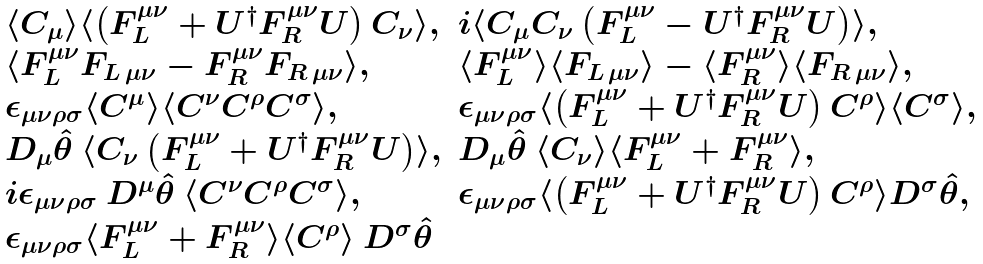<formula> <loc_0><loc_0><loc_500><loc_500>\begin{array} { l l } \langle C _ { \mu } \rangle \langle \left ( F _ { L } ^ { \mu \nu } + U ^ { \dagger } F _ { R } ^ { \mu \nu } U \right ) C _ { \nu } \rangle , & i \langle C _ { \mu } C _ { \nu } \left ( F _ { L } ^ { \mu \nu } - U ^ { \dagger } F _ { R } ^ { \mu \nu } U \right ) \rangle , \\ \langle F _ { L } ^ { \mu \nu } F _ { L \, \mu \nu } - F _ { R } ^ { \mu \nu } F _ { R \, \mu \nu } \rangle , & \langle F _ { L } ^ { \mu \nu } \rangle \langle F _ { L \, \mu \nu } \rangle - \langle F _ { R } ^ { \mu \nu } \rangle \langle F _ { R \, \mu \nu } \rangle , \\ \epsilon _ { \mu \nu \rho \sigma } \langle C ^ { \mu } \rangle \langle C ^ { \nu } C ^ { \rho } C ^ { \sigma } \rangle , & \epsilon _ { \mu \nu \rho \sigma } \langle \left ( F _ { L } ^ { \mu \nu } + U ^ { \dagger } F _ { R } ^ { \mu \nu } U \right ) C ^ { \rho } \rangle \langle C ^ { \sigma } \rangle , \\ D _ { \mu } \hat { \theta } \ \langle C _ { \nu } \left ( F _ { L } ^ { \mu \nu } + U ^ { \dagger } F _ { R } ^ { \mu \nu } U \right ) \rangle , & D _ { \mu } \hat { \theta } \ \langle C _ { \nu } \rangle \langle F _ { L } ^ { \mu \nu } + F _ { R } ^ { \mu \nu } \rangle , \\ i \epsilon _ { \mu \nu \rho \sigma } \ D ^ { \mu } \hat { \theta } \ \langle C ^ { \nu } C ^ { \rho } C ^ { \sigma } \rangle , & \epsilon _ { \mu \nu \rho \sigma } \langle \left ( F _ { L } ^ { \mu \nu } + U ^ { \dagger } F _ { R } ^ { \mu \nu } U \right ) C ^ { \rho } \rangle D ^ { \sigma } \hat { \theta } , \\ \epsilon _ { \mu \nu \rho \sigma } \langle F _ { L } ^ { \mu \nu } + F _ { R } ^ { \mu \nu } \rangle \langle C ^ { \rho } \rangle \ D ^ { \sigma } \hat { \theta } & \end{array}</formula> 